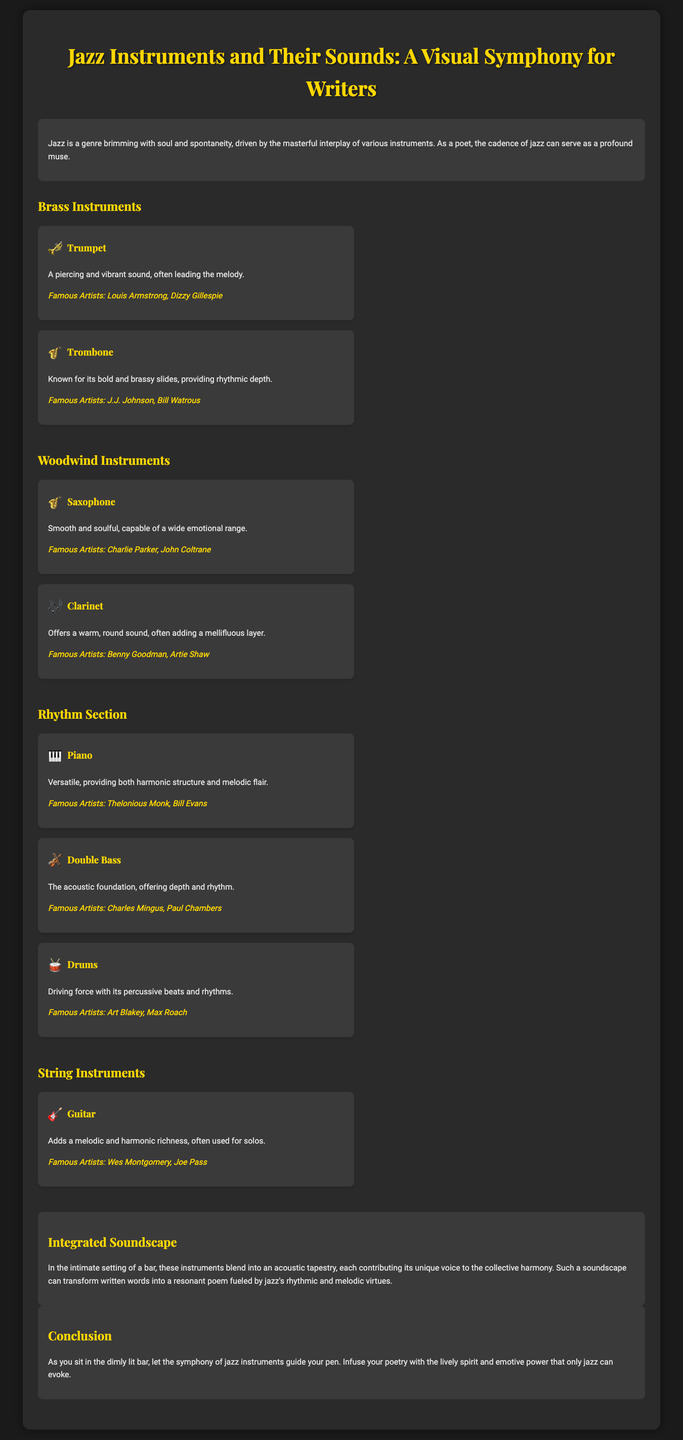what is the title of the document? The title of the document is prominently displayed at the top and identifies the subject matter.
Answer: Jazz Instruments and Their Sounds: A Visual Symphony for Writers who is a famous artist associated with the trumpet? The document lists famous artists for each instrument, covering their notable contributions to jazz.
Answer: Louis Armstrong what sound does the saxophone produce? The saxophone's description highlights its characteristic sound, emphasizing its soulful quality.
Answer: Smooth and soulful how many types of brass instruments are mentioned? The document provides information on the types of instruments categorized under brass instruments.
Answer: Two what role does the piano play in jazz? The document describes the role of the piano within the rhythm section of jazz music.
Answer: Harmonic structure and melodic flair who are famous artists that play double bass? The document identifies notable artists associated with specific jazz instruments for context.
Answer: Charles Mingus, Paul Chambers what is the main theme of the integrated soundscape section? The integrated soundscape section reflects on the overall contribution of jazz instruments to create a unique auditory experience.
Answer: Acoustic tapestry how does the document suggest jazz influences poetry? The conclusion provides a perspective on how jazz can inspire and enhance the creative process for writers, particularly poets.
Answer: Guide your pen 